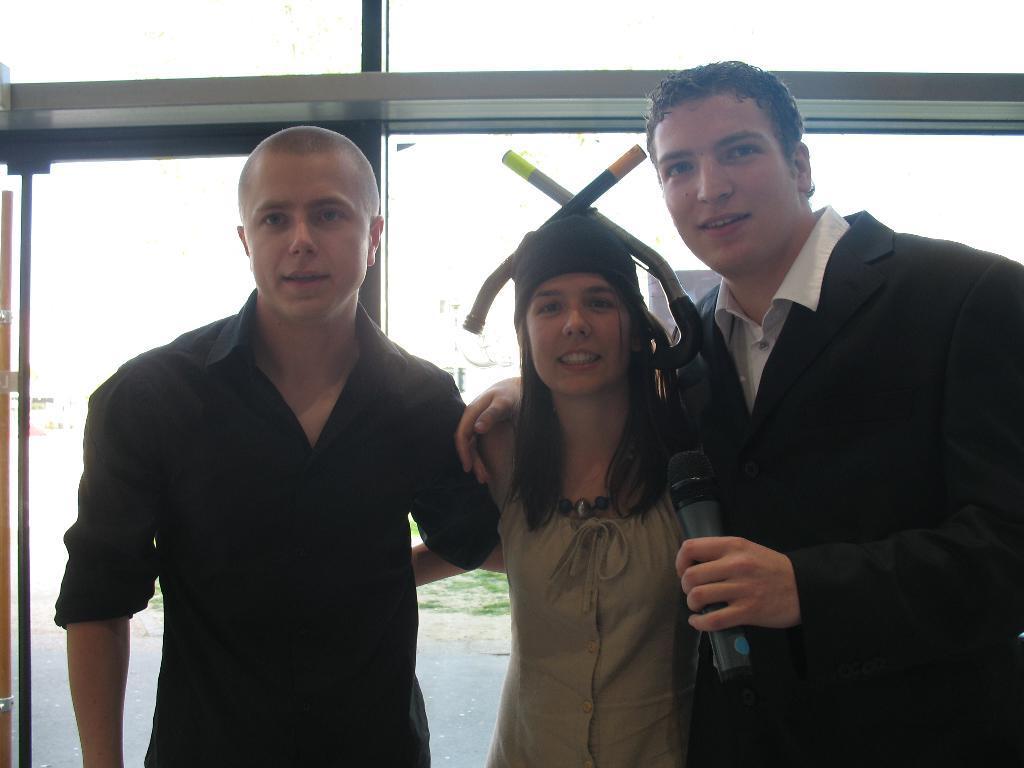Please provide a concise description of this image. Here I can see three persons standing, smiling and giving pose for the picture. The man who is on the right side is holding a mike in the hand. At the back of these people there is a glass. 